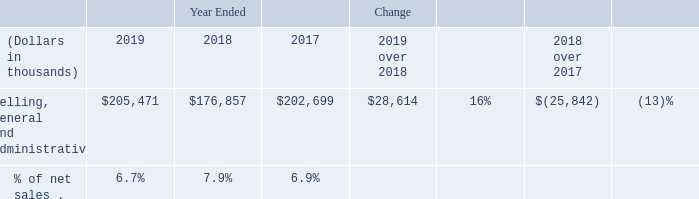Selling, general and administrative
Selling, general and administrative expense consists primarily of salaries and other personnel-related costs, professional fees, insurance costs, and other business development and selling expenses.
The following table shows selling, general and administrative expense for the years ended December 31, 2019, 2018, and 2017:
Selling, general and administrative expense in 2019 increased compared to 2018 primarily due to higher employee compensation expense, lower accretion expense in 2018 associated with the reduction in our module collection and recycling liability described above, and higher professional fees.
What are the components in selling, general and administrative expense? Selling, general and administrative expense consists primarily of salaries and other personnel-related costs, professional fees, insurance costs, and other business development and selling expenses. What are the reasons for higher selling, general and administrative expense in 2019 as compared to 2018? Selling, general and administrative expense in 2019 increased compared to 2018 primarily due to higher employee compensation expense, lower accretion expense in 2018 associated with the reduction in our module collection and recycling liability described above, and higher professional fees. What is the percentage of net sales in 2019? 6.7%. What is the amount of net sales in 2019?
Answer scale should be: thousand. 205,471 / 6.7% 
Answer: 3066731.34. What is the net difference in selling, general and administrative expense between 2019 and 2017?
Answer scale should be: thousand. 205,471 - 202,699 
Answer: 2772. What is the difference in net sales amount in 2019 and 2018?
Answer scale should be: thousand. (205,471 / 6.7%) - (176,857 / 7.9%) 
Answer: 828035.14. 